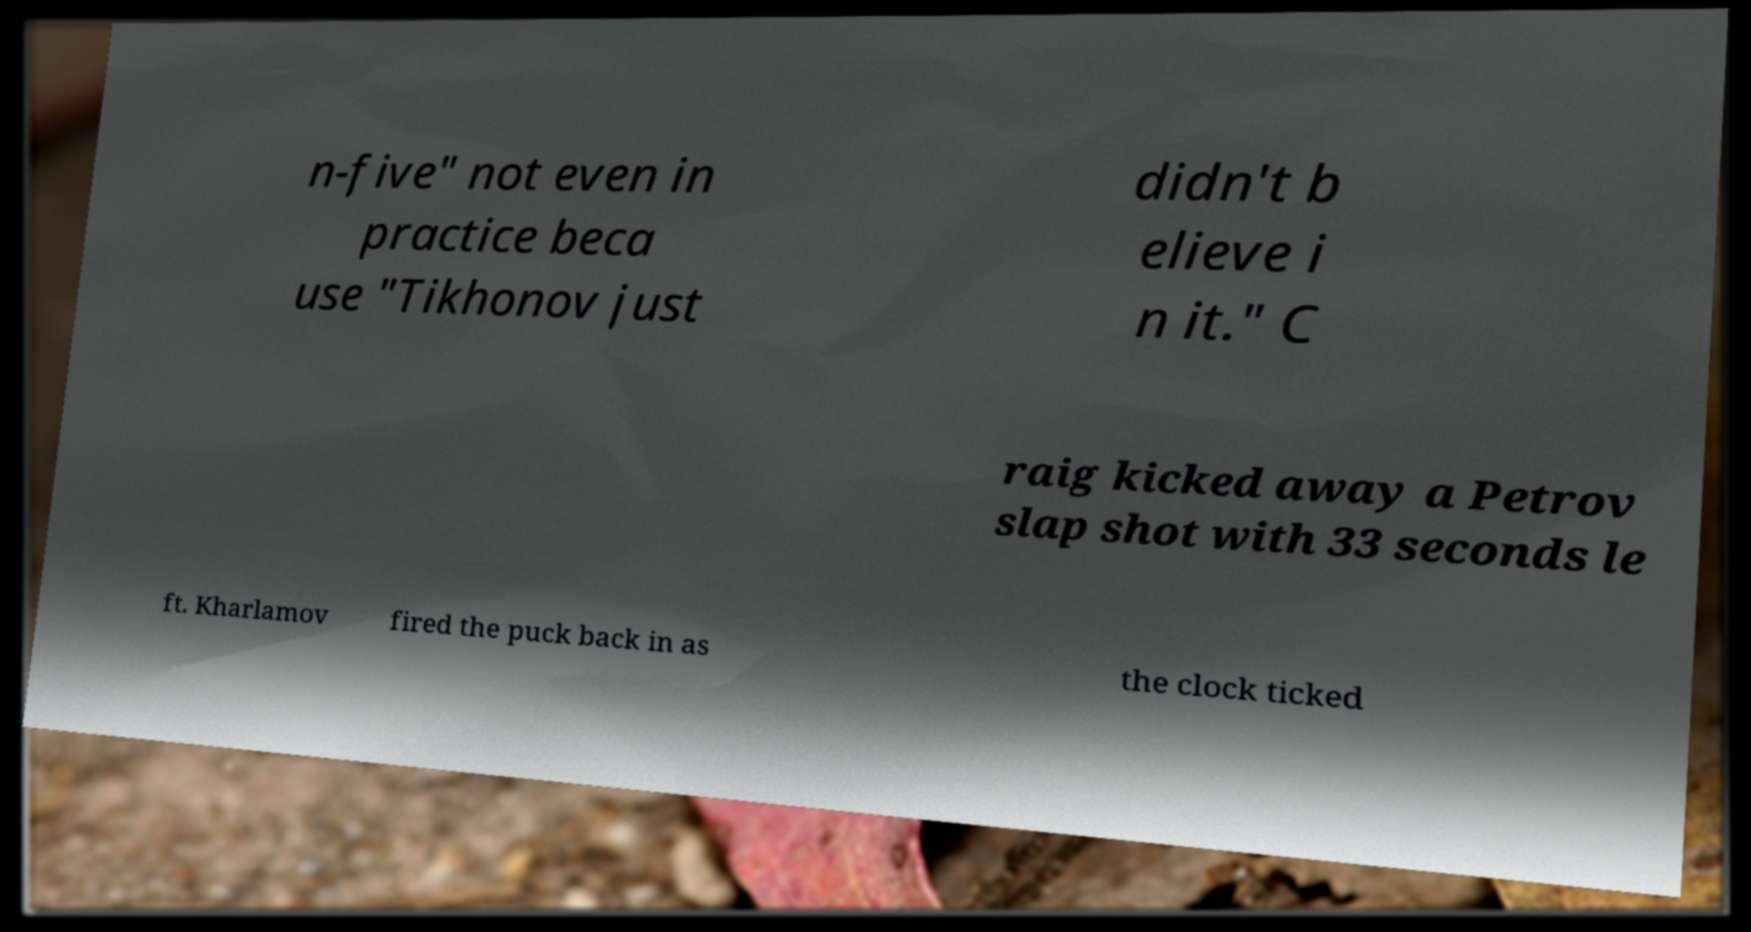For documentation purposes, I need the text within this image transcribed. Could you provide that? n-five" not even in practice beca use "Tikhonov just didn't b elieve i n it." C raig kicked away a Petrov slap shot with 33 seconds le ft. Kharlamov fired the puck back in as the clock ticked 